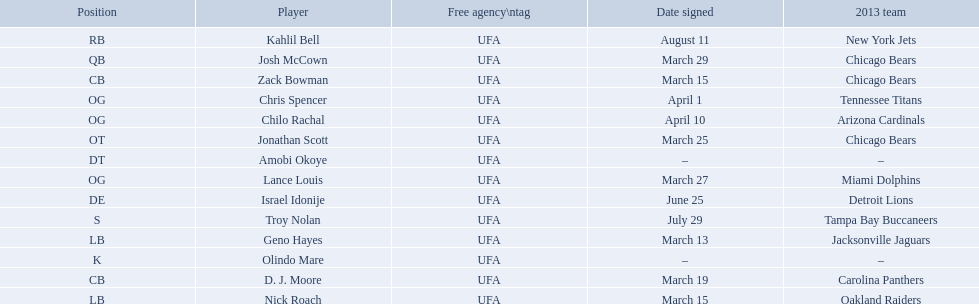What are all the dates signed? March 29, August 11, March 27, April 1, April 10, March 25, June 25, March 13, March 15, March 15, March 19, July 29. Which of these are duplicates? March 15, March 15. Who has the same one as nick roach? Zack Bowman. 